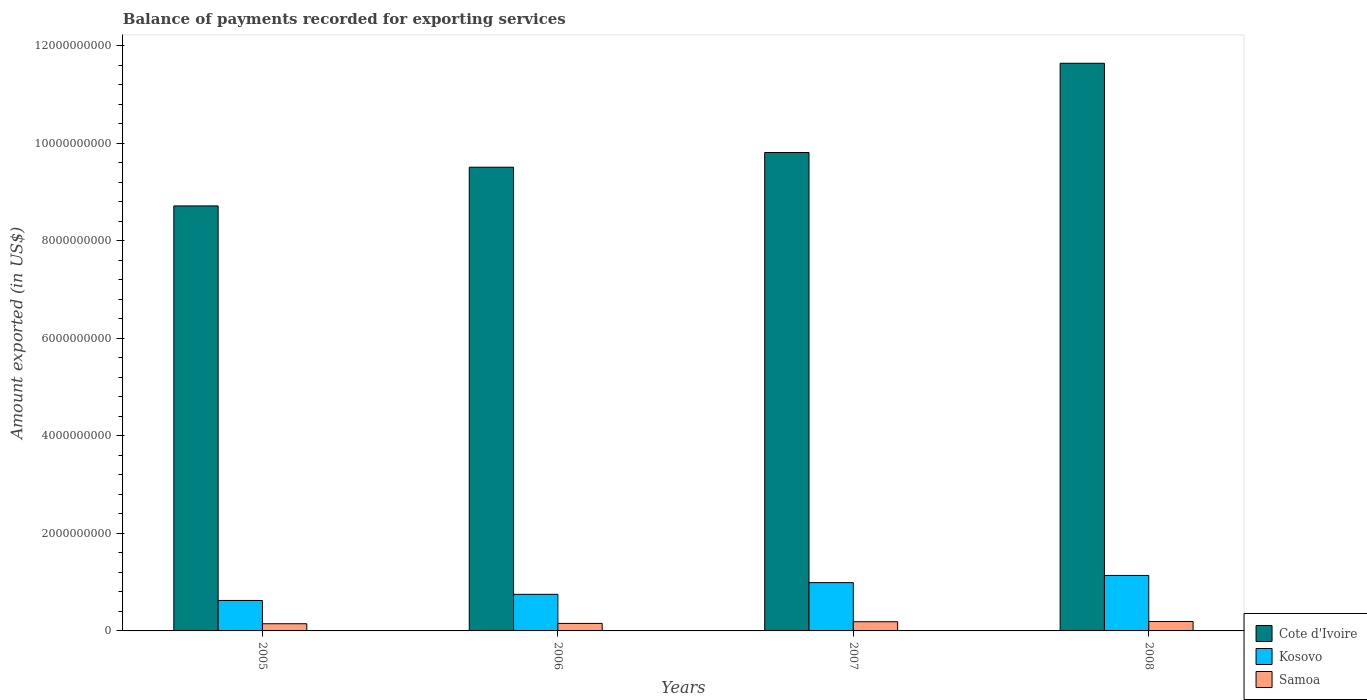How many different coloured bars are there?
Provide a succinct answer. 3. Are the number of bars per tick equal to the number of legend labels?
Ensure brevity in your answer.  Yes. How many bars are there on the 4th tick from the right?
Offer a very short reply. 3. What is the label of the 4th group of bars from the left?
Provide a short and direct response. 2008. What is the amount exported in Cote d'Ivoire in 2007?
Make the answer very short. 9.81e+09. Across all years, what is the maximum amount exported in Samoa?
Provide a succinct answer. 1.93e+08. Across all years, what is the minimum amount exported in Cote d'Ivoire?
Provide a succinct answer. 8.72e+09. In which year was the amount exported in Kosovo maximum?
Offer a very short reply. 2008. What is the total amount exported in Kosovo in the graph?
Your answer should be very brief. 3.50e+09. What is the difference between the amount exported in Kosovo in 2005 and that in 2007?
Make the answer very short. -3.66e+08. What is the difference between the amount exported in Samoa in 2008 and the amount exported in Kosovo in 2007?
Keep it short and to the point. -7.97e+08. What is the average amount exported in Cote d'Ivoire per year?
Your response must be concise. 9.92e+09. In the year 2006, what is the difference between the amount exported in Cote d'Ivoire and amount exported in Kosovo?
Keep it short and to the point. 8.76e+09. What is the ratio of the amount exported in Cote d'Ivoire in 2006 to that in 2007?
Offer a very short reply. 0.97. What is the difference between the highest and the second highest amount exported in Kosovo?
Give a very brief answer. 1.47e+08. What is the difference between the highest and the lowest amount exported in Kosovo?
Your answer should be compact. 5.13e+08. Is the sum of the amount exported in Samoa in 2007 and 2008 greater than the maximum amount exported in Cote d'Ivoire across all years?
Give a very brief answer. No. What does the 1st bar from the left in 2005 represents?
Provide a short and direct response. Cote d'Ivoire. What does the 2nd bar from the right in 2005 represents?
Your response must be concise. Kosovo. How many bars are there?
Make the answer very short. 12. What is the difference between two consecutive major ticks on the Y-axis?
Your answer should be compact. 2.00e+09. Does the graph contain grids?
Keep it short and to the point. No. How many legend labels are there?
Provide a succinct answer. 3. What is the title of the graph?
Provide a short and direct response. Balance of payments recorded for exporting services. What is the label or title of the Y-axis?
Provide a succinct answer. Amount exported (in US$). What is the Amount exported (in US$) of Cote d'Ivoire in 2005?
Provide a succinct answer. 8.72e+09. What is the Amount exported (in US$) of Kosovo in 2005?
Offer a very short reply. 6.25e+08. What is the Amount exported (in US$) of Samoa in 2005?
Make the answer very short. 1.47e+08. What is the Amount exported (in US$) in Cote d'Ivoire in 2006?
Make the answer very short. 9.51e+09. What is the Amount exported (in US$) of Kosovo in 2006?
Your answer should be compact. 7.50e+08. What is the Amount exported (in US$) of Samoa in 2006?
Give a very brief answer. 1.54e+08. What is the Amount exported (in US$) in Cote d'Ivoire in 2007?
Make the answer very short. 9.81e+09. What is the Amount exported (in US$) of Kosovo in 2007?
Your answer should be compact. 9.91e+08. What is the Amount exported (in US$) of Samoa in 2007?
Give a very brief answer. 1.89e+08. What is the Amount exported (in US$) in Cote d'Ivoire in 2008?
Ensure brevity in your answer.  1.16e+1. What is the Amount exported (in US$) of Kosovo in 2008?
Keep it short and to the point. 1.14e+09. What is the Amount exported (in US$) of Samoa in 2008?
Your answer should be compact. 1.93e+08. Across all years, what is the maximum Amount exported (in US$) of Cote d'Ivoire?
Your answer should be compact. 1.16e+1. Across all years, what is the maximum Amount exported (in US$) of Kosovo?
Offer a terse response. 1.14e+09. Across all years, what is the maximum Amount exported (in US$) in Samoa?
Make the answer very short. 1.93e+08. Across all years, what is the minimum Amount exported (in US$) in Cote d'Ivoire?
Ensure brevity in your answer.  8.72e+09. Across all years, what is the minimum Amount exported (in US$) in Kosovo?
Give a very brief answer. 6.25e+08. Across all years, what is the minimum Amount exported (in US$) in Samoa?
Your answer should be compact. 1.47e+08. What is the total Amount exported (in US$) of Cote d'Ivoire in the graph?
Your answer should be compact. 3.97e+1. What is the total Amount exported (in US$) in Kosovo in the graph?
Keep it short and to the point. 3.50e+09. What is the total Amount exported (in US$) of Samoa in the graph?
Offer a very short reply. 6.83e+08. What is the difference between the Amount exported (in US$) of Cote d'Ivoire in 2005 and that in 2006?
Your response must be concise. -7.94e+08. What is the difference between the Amount exported (in US$) in Kosovo in 2005 and that in 2006?
Offer a terse response. -1.26e+08. What is the difference between the Amount exported (in US$) of Samoa in 2005 and that in 2006?
Make the answer very short. -6.88e+06. What is the difference between the Amount exported (in US$) in Cote d'Ivoire in 2005 and that in 2007?
Your response must be concise. -1.10e+09. What is the difference between the Amount exported (in US$) in Kosovo in 2005 and that in 2007?
Provide a short and direct response. -3.66e+08. What is the difference between the Amount exported (in US$) of Samoa in 2005 and that in 2007?
Give a very brief answer. -4.13e+07. What is the difference between the Amount exported (in US$) in Cote d'Ivoire in 2005 and that in 2008?
Provide a short and direct response. -2.93e+09. What is the difference between the Amount exported (in US$) of Kosovo in 2005 and that in 2008?
Offer a terse response. -5.13e+08. What is the difference between the Amount exported (in US$) in Samoa in 2005 and that in 2008?
Offer a very short reply. -4.62e+07. What is the difference between the Amount exported (in US$) in Cote d'Ivoire in 2006 and that in 2007?
Your answer should be compact. -3.01e+08. What is the difference between the Amount exported (in US$) of Kosovo in 2006 and that in 2007?
Provide a succinct answer. -2.40e+08. What is the difference between the Amount exported (in US$) in Samoa in 2006 and that in 2007?
Keep it short and to the point. -3.44e+07. What is the difference between the Amount exported (in US$) of Cote d'Ivoire in 2006 and that in 2008?
Make the answer very short. -2.13e+09. What is the difference between the Amount exported (in US$) in Kosovo in 2006 and that in 2008?
Your answer should be very brief. -3.87e+08. What is the difference between the Amount exported (in US$) in Samoa in 2006 and that in 2008?
Offer a terse response. -3.93e+07. What is the difference between the Amount exported (in US$) of Cote d'Ivoire in 2007 and that in 2008?
Your response must be concise. -1.83e+09. What is the difference between the Amount exported (in US$) of Kosovo in 2007 and that in 2008?
Provide a succinct answer. -1.47e+08. What is the difference between the Amount exported (in US$) of Samoa in 2007 and that in 2008?
Provide a short and direct response. -4.95e+06. What is the difference between the Amount exported (in US$) in Cote d'Ivoire in 2005 and the Amount exported (in US$) in Kosovo in 2006?
Give a very brief answer. 7.97e+09. What is the difference between the Amount exported (in US$) in Cote d'Ivoire in 2005 and the Amount exported (in US$) in Samoa in 2006?
Keep it short and to the point. 8.56e+09. What is the difference between the Amount exported (in US$) of Kosovo in 2005 and the Amount exported (in US$) of Samoa in 2006?
Your answer should be very brief. 4.71e+08. What is the difference between the Amount exported (in US$) in Cote d'Ivoire in 2005 and the Amount exported (in US$) in Kosovo in 2007?
Offer a terse response. 7.73e+09. What is the difference between the Amount exported (in US$) in Cote d'Ivoire in 2005 and the Amount exported (in US$) in Samoa in 2007?
Your response must be concise. 8.53e+09. What is the difference between the Amount exported (in US$) in Kosovo in 2005 and the Amount exported (in US$) in Samoa in 2007?
Your response must be concise. 4.36e+08. What is the difference between the Amount exported (in US$) of Cote d'Ivoire in 2005 and the Amount exported (in US$) of Kosovo in 2008?
Make the answer very short. 7.58e+09. What is the difference between the Amount exported (in US$) in Cote d'Ivoire in 2005 and the Amount exported (in US$) in Samoa in 2008?
Your response must be concise. 8.52e+09. What is the difference between the Amount exported (in US$) of Kosovo in 2005 and the Amount exported (in US$) of Samoa in 2008?
Make the answer very short. 4.31e+08. What is the difference between the Amount exported (in US$) of Cote d'Ivoire in 2006 and the Amount exported (in US$) of Kosovo in 2007?
Provide a succinct answer. 8.52e+09. What is the difference between the Amount exported (in US$) of Cote d'Ivoire in 2006 and the Amount exported (in US$) of Samoa in 2007?
Give a very brief answer. 9.32e+09. What is the difference between the Amount exported (in US$) of Kosovo in 2006 and the Amount exported (in US$) of Samoa in 2007?
Offer a very short reply. 5.62e+08. What is the difference between the Amount exported (in US$) of Cote d'Ivoire in 2006 and the Amount exported (in US$) of Kosovo in 2008?
Make the answer very short. 8.37e+09. What is the difference between the Amount exported (in US$) in Cote d'Ivoire in 2006 and the Amount exported (in US$) in Samoa in 2008?
Offer a very short reply. 9.32e+09. What is the difference between the Amount exported (in US$) in Kosovo in 2006 and the Amount exported (in US$) in Samoa in 2008?
Give a very brief answer. 5.57e+08. What is the difference between the Amount exported (in US$) of Cote d'Ivoire in 2007 and the Amount exported (in US$) of Kosovo in 2008?
Offer a very short reply. 8.67e+09. What is the difference between the Amount exported (in US$) in Cote d'Ivoire in 2007 and the Amount exported (in US$) in Samoa in 2008?
Keep it short and to the point. 9.62e+09. What is the difference between the Amount exported (in US$) in Kosovo in 2007 and the Amount exported (in US$) in Samoa in 2008?
Your response must be concise. 7.97e+08. What is the average Amount exported (in US$) in Cote d'Ivoire per year?
Keep it short and to the point. 9.92e+09. What is the average Amount exported (in US$) of Kosovo per year?
Offer a terse response. 8.76e+08. What is the average Amount exported (in US$) of Samoa per year?
Offer a very short reply. 1.71e+08. In the year 2005, what is the difference between the Amount exported (in US$) of Cote d'Ivoire and Amount exported (in US$) of Kosovo?
Give a very brief answer. 8.09e+09. In the year 2005, what is the difference between the Amount exported (in US$) in Cote d'Ivoire and Amount exported (in US$) in Samoa?
Offer a very short reply. 8.57e+09. In the year 2005, what is the difference between the Amount exported (in US$) in Kosovo and Amount exported (in US$) in Samoa?
Your answer should be compact. 4.78e+08. In the year 2006, what is the difference between the Amount exported (in US$) of Cote d'Ivoire and Amount exported (in US$) of Kosovo?
Give a very brief answer. 8.76e+09. In the year 2006, what is the difference between the Amount exported (in US$) in Cote d'Ivoire and Amount exported (in US$) in Samoa?
Ensure brevity in your answer.  9.36e+09. In the year 2006, what is the difference between the Amount exported (in US$) in Kosovo and Amount exported (in US$) in Samoa?
Your response must be concise. 5.96e+08. In the year 2007, what is the difference between the Amount exported (in US$) of Cote d'Ivoire and Amount exported (in US$) of Kosovo?
Give a very brief answer. 8.82e+09. In the year 2007, what is the difference between the Amount exported (in US$) in Cote d'Ivoire and Amount exported (in US$) in Samoa?
Your response must be concise. 9.62e+09. In the year 2007, what is the difference between the Amount exported (in US$) of Kosovo and Amount exported (in US$) of Samoa?
Provide a short and direct response. 8.02e+08. In the year 2008, what is the difference between the Amount exported (in US$) of Cote d'Ivoire and Amount exported (in US$) of Kosovo?
Ensure brevity in your answer.  1.05e+1. In the year 2008, what is the difference between the Amount exported (in US$) in Cote d'Ivoire and Amount exported (in US$) in Samoa?
Make the answer very short. 1.14e+1. In the year 2008, what is the difference between the Amount exported (in US$) in Kosovo and Amount exported (in US$) in Samoa?
Provide a succinct answer. 9.44e+08. What is the ratio of the Amount exported (in US$) in Cote d'Ivoire in 2005 to that in 2006?
Provide a succinct answer. 0.92. What is the ratio of the Amount exported (in US$) in Kosovo in 2005 to that in 2006?
Your response must be concise. 0.83. What is the ratio of the Amount exported (in US$) in Samoa in 2005 to that in 2006?
Ensure brevity in your answer.  0.96. What is the ratio of the Amount exported (in US$) in Cote d'Ivoire in 2005 to that in 2007?
Offer a very short reply. 0.89. What is the ratio of the Amount exported (in US$) of Kosovo in 2005 to that in 2007?
Offer a terse response. 0.63. What is the ratio of the Amount exported (in US$) of Samoa in 2005 to that in 2007?
Offer a very short reply. 0.78. What is the ratio of the Amount exported (in US$) of Cote d'Ivoire in 2005 to that in 2008?
Your answer should be compact. 0.75. What is the ratio of the Amount exported (in US$) of Kosovo in 2005 to that in 2008?
Make the answer very short. 0.55. What is the ratio of the Amount exported (in US$) in Samoa in 2005 to that in 2008?
Ensure brevity in your answer.  0.76. What is the ratio of the Amount exported (in US$) of Cote d'Ivoire in 2006 to that in 2007?
Your answer should be compact. 0.97. What is the ratio of the Amount exported (in US$) in Kosovo in 2006 to that in 2007?
Keep it short and to the point. 0.76. What is the ratio of the Amount exported (in US$) in Samoa in 2006 to that in 2007?
Your answer should be very brief. 0.82. What is the ratio of the Amount exported (in US$) in Cote d'Ivoire in 2006 to that in 2008?
Keep it short and to the point. 0.82. What is the ratio of the Amount exported (in US$) in Kosovo in 2006 to that in 2008?
Give a very brief answer. 0.66. What is the ratio of the Amount exported (in US$) in Samoa in 2006 to that in 2008?
Make the answer very short. 0.8. What is the ratio of the Amount exported (in US$) in Cote d'Ivoire in 2007 to that in 2008?
Your answer should be compact. 0.84. What is the ratio of the Amount exported (in US$) in Kosovo in 2007 to that in 2008?
Provide a short and direct response. 0.87. What is the ratio of the Amount exported (in US$) in Samoa in 2007 to that in 2008?
Offer a terse response. 0.97. What is the difference between the highest and the second highest Amount exported (in US$) of Cote d'Ivoire?
Your answer should be compact. 1.83e+09. What is the difference between the highest and the second highest Amount exported (in US$) of Kosovo?
Your answer should be compact. 1.47e+08. What is the difference between the highest and the second highest Amount exported (in US$) of Samoa?
Your answer should be compact. 4.95e+06. What is the difference between the highest and the lowest Amount exported (in US$) in Cote d'Ivoire?
Your answer should be very brief. 2.93e+09. What is the difference between the highest and the lowest Amount exported (in US$) of Kosovo?
Give a very brief answer. 5.13e+08. What is the difference between the highest and the lowest Amount exported (in US$) in Samoa?
Give a very brief answer. 4.62e+07. 